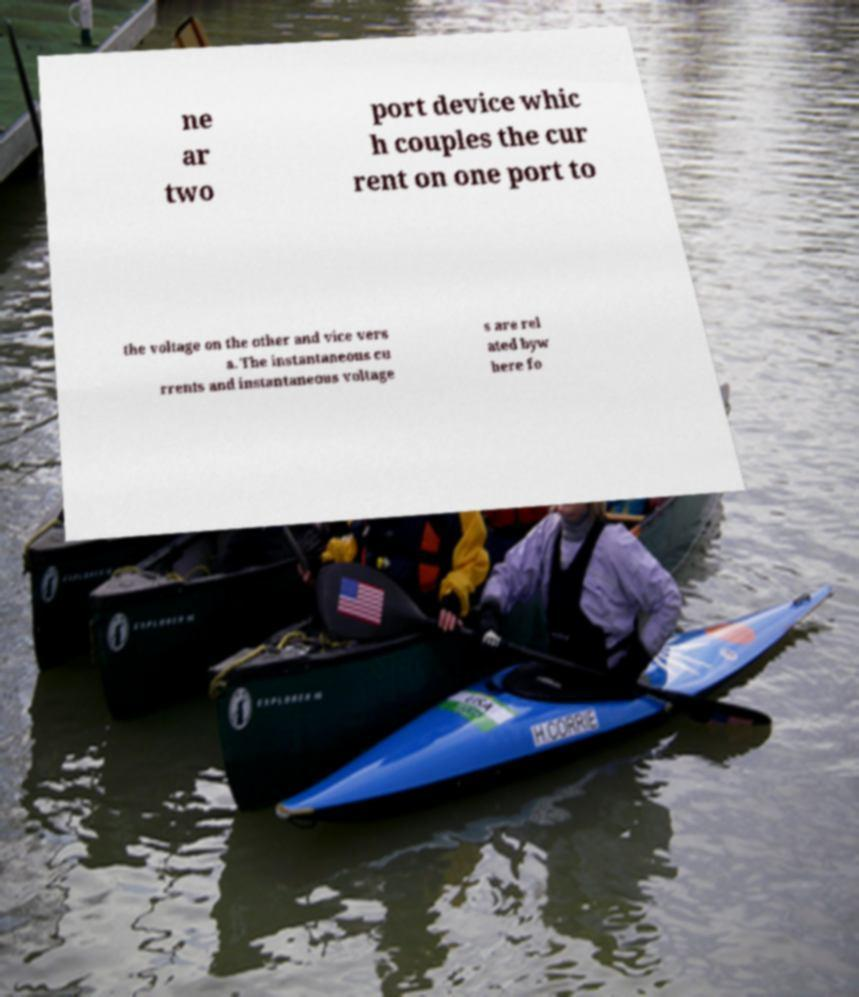Can you read and provide the text displayed in the image?This photo seems to have some interesting text. Can you extract and type it out for me? ne ar two port device whic h couples the cur rent on one port to the voltage on the other and vice vers a. The instantaneous cu rrents and instantaneous voltage s are rel ated byw here fo 